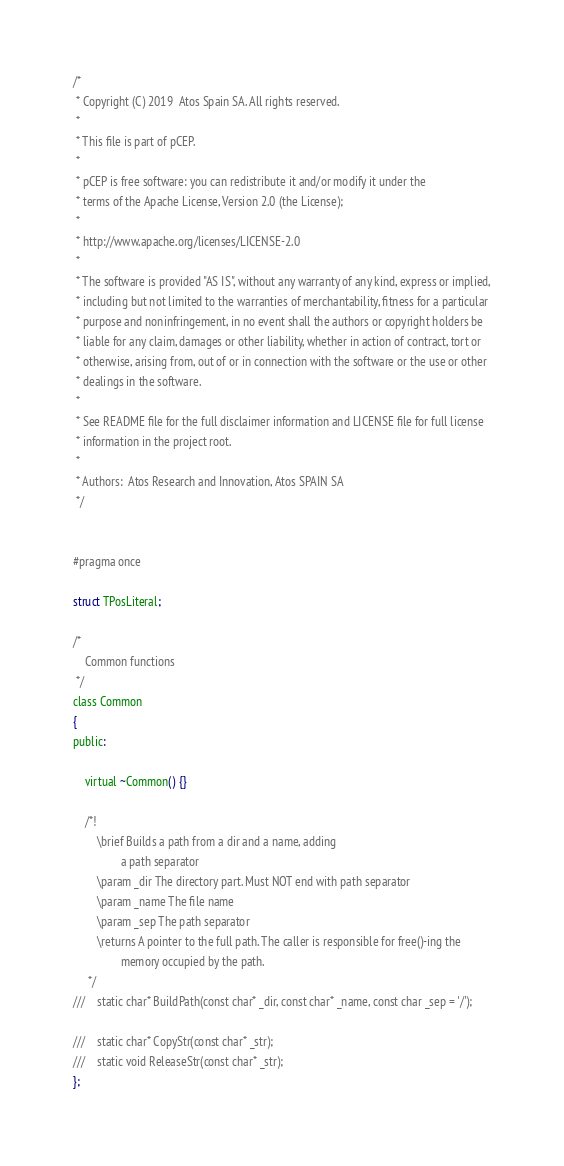<code> <loc_0><loc_0><loc_500><loc_500><_C_>/*
 * Copyright (C) 2019  Atos Spain SA. All rights reserved.
 *
 * This file is part of pCEP.
 *
 * pCEP is free software: you can redistribute it and/or modify it under the
 * terms of the Apache License, Version 2.0 (the License);
 *
 * http://www.apache.org/licenses/LICENSE-2.0
 *
 * The software is provided "AS IS", without any warranty of any kind, express or implied,
 * including but not limited to the warranties of merchantability, fitness for a particular
 * purpose and noninfringement, in no event shall the authors or copyright holders be
 * liable for any claim, damages or other liability, whether in action of contract, tort or
 * otherwise, arising from, out of or in connection with the software or the use or other
 * dealings in the software.
 *
 * See README file for the full disclaimer information and LICENSE file for full license
 * information in the project root.
 *
 * Authors:  Atos Research and Innovation, Atos SPAIN SA
 */


#pragma once

struct TPosLiteral;

/* 
    Common functions	
 */
class Common
{
public:

    virtual ~Common() {}

    /*!
        \brief Builds a path from a dir and a name, adding
                a path separator
        \param _dir The directory part. Must NOT end with path separator
        \param _name The file name
        \param _sep The path separator
        \returns A pointer to the full path. The caller is responsible for free()-ing the
                memory occupied by the path.
     */
///    static char* BuildPath(const char* _dir, const char* _name, const char _sep = '/');

///    static char* CopyStr(const char* _str);
///    static void ReleaseStr(const char* _str);
};


</code> 